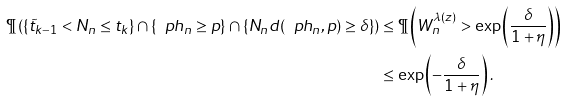Convert formula to latex. <formula><loc_0><loc_0><loc_500><loc_500>\P \left ( \left \{ \tilde { t } _ { k - 1 } < N _ { n } \leq t _ { k } \right \} \cap \left \{ \ p h _ { n } \geq p \right \} \cap \left \{ N _ { n } d ( \ p h _ { n } , p ) \geq \delta \right \} \right ) & \leq \P \left ( W ^ { \lambda ( z ) } _ { n } > \exp \left ( \frac { \delta } { 1 + \eta } \right ) \right ) \\ & \leq \exp \left ( - \frac { \delta } { 1 + \eta } \right ) .</formula> 